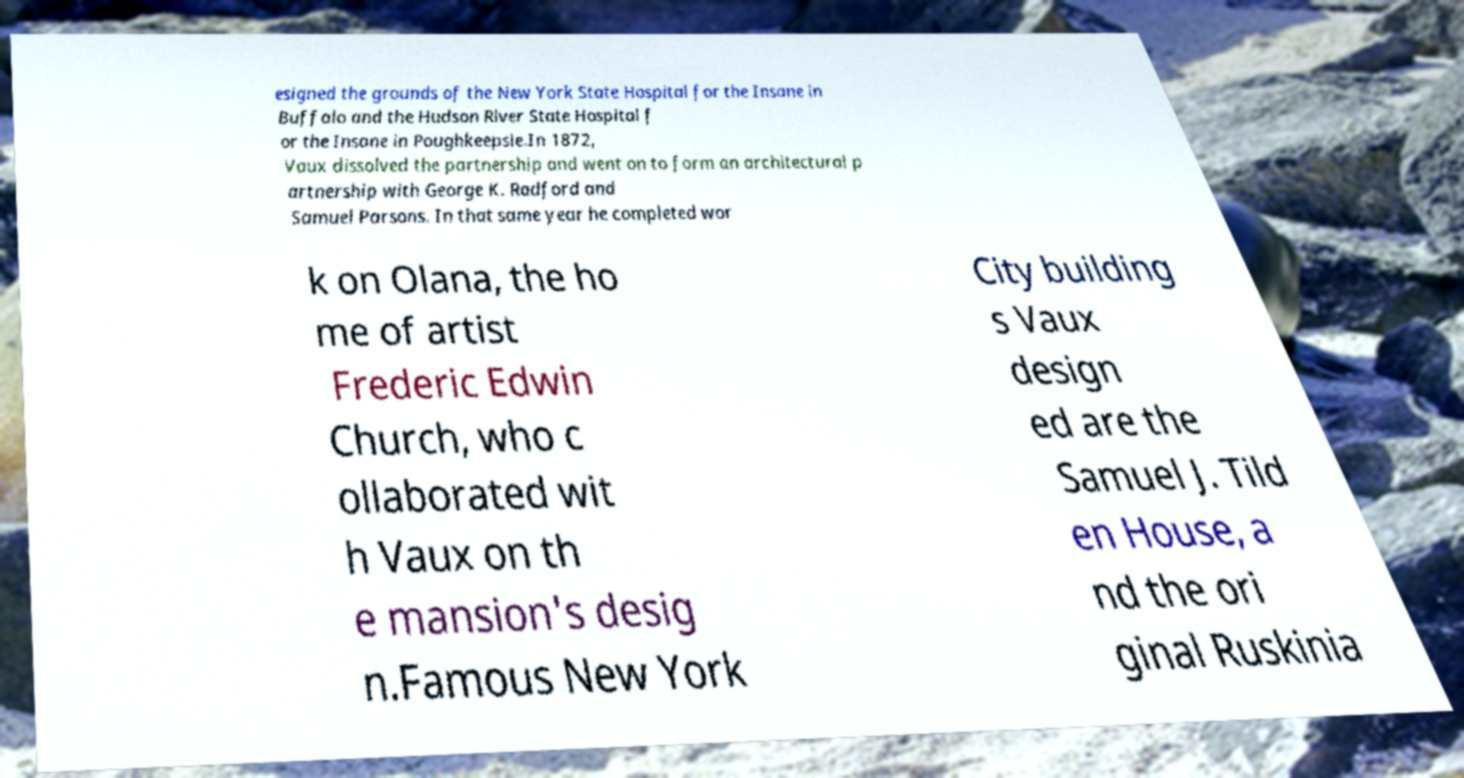For documentation purposes, I need the text within this image transcribed. Could you provide that? esigned the grounds of the New York State Hospital for the Insane in Buffalo and the Hudson River State Hospital f or the Insane in Poughkeepsie.In 1872, Vaux dissolved the partnership and went on to form an architectural p artnership with George K. Radford and Samuel Parsons. In that same year he completed wor k on Olana, the ho me of artist Frederic Edwin Church, who c ollaborated wit h Vaux on th e mansion's desig n.Famous New York City building s Vaux design ed are the Samuel J. Tild en House, a nd the ori ginal Ruskinia 